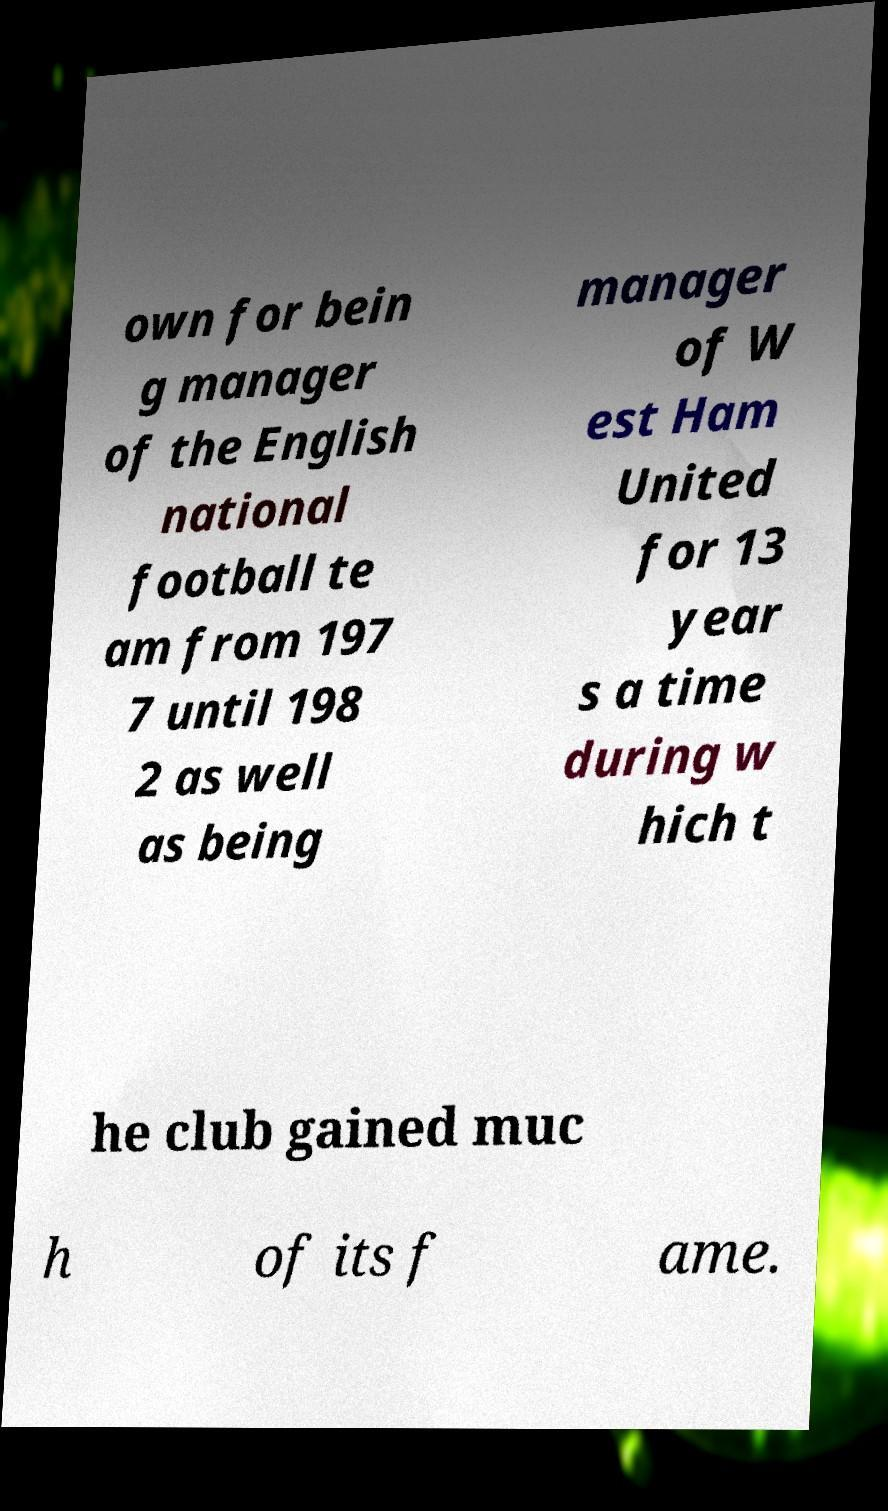For documentation purposes, I need the text within this image transcribed. Could you provide that? own for bein g manager of the English national football te am from 197 7 until 198 2 as well as being manager of W est Ham United for 13 year s a time during w hich t he club gained muc h of its f ame. 